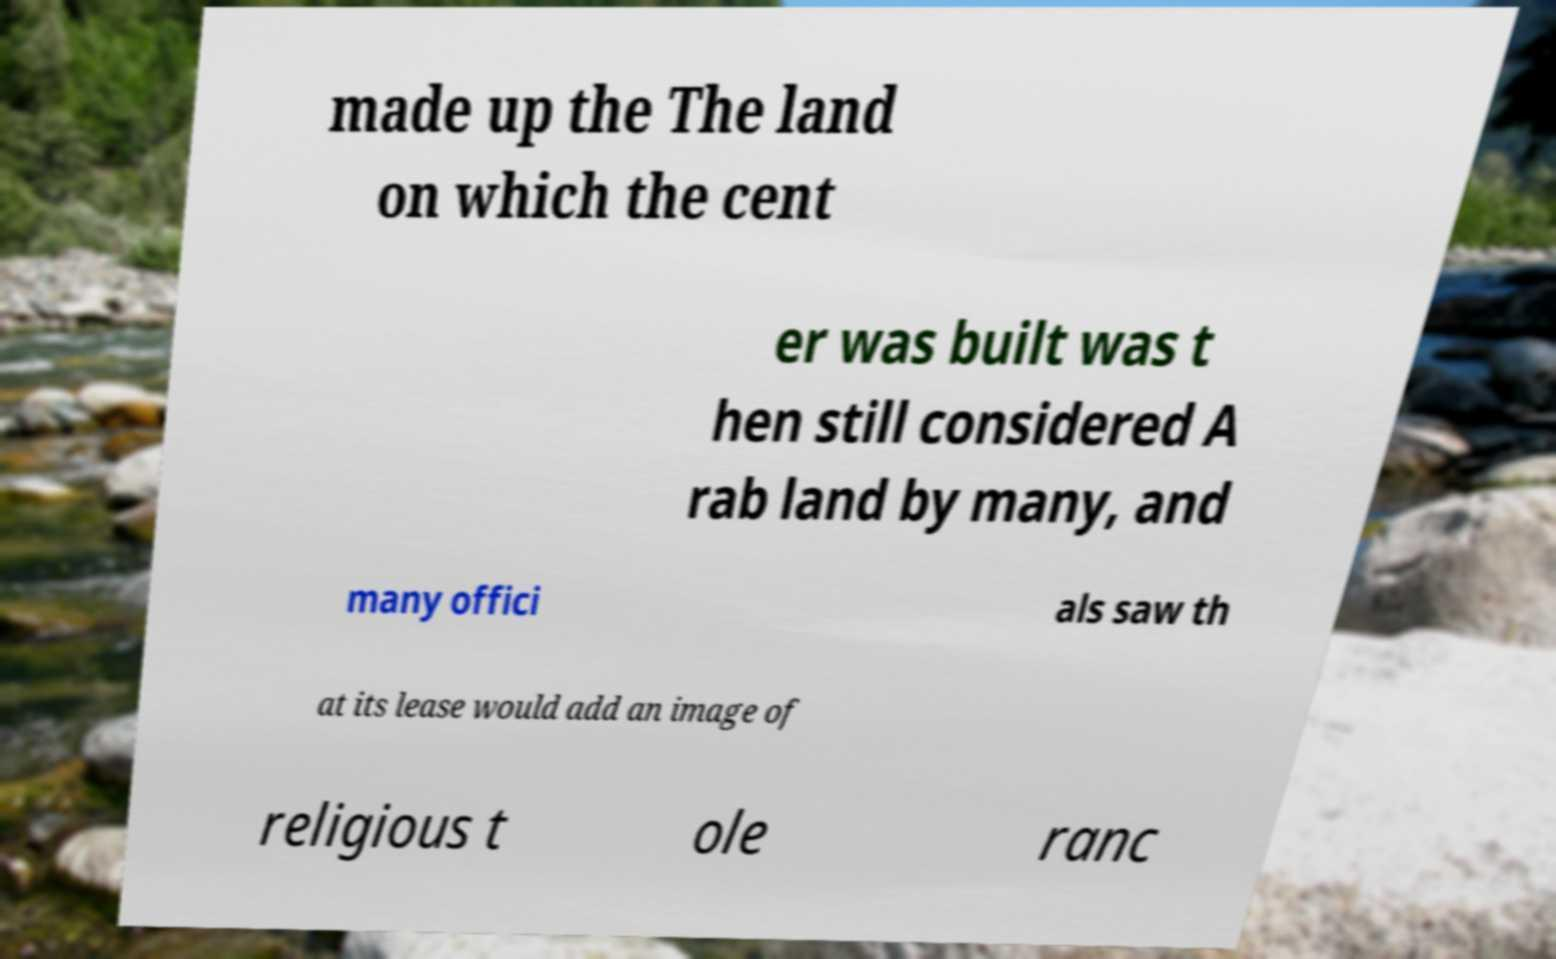Please read and relay the text visible in this image. What does it say? made up the The land on which the cent er was built was t hen still considered A rab land by many, and many offici als saw th at its lease would add an image of religious t ole ranc 